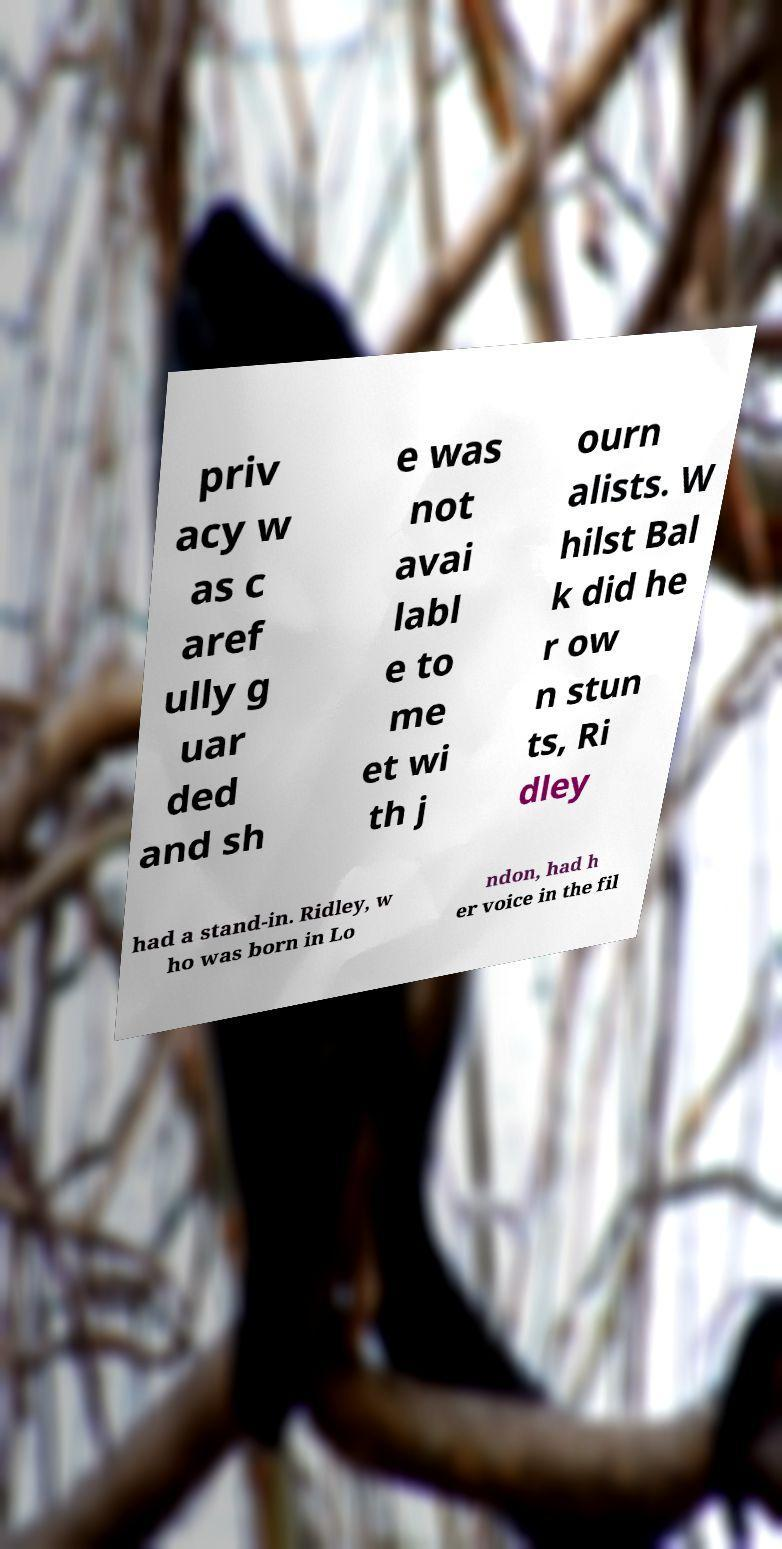Could you extract and type out the text from this image? priv acy w as c aref ully g uar ded and sh e was not avai labl e to me et wi th j ourn alists. W hilst Bal k did he r ow n stun ts, Ri dley had a stand-in. Ridley, w ho was born in Lo ndon, had h er voice in the fil 